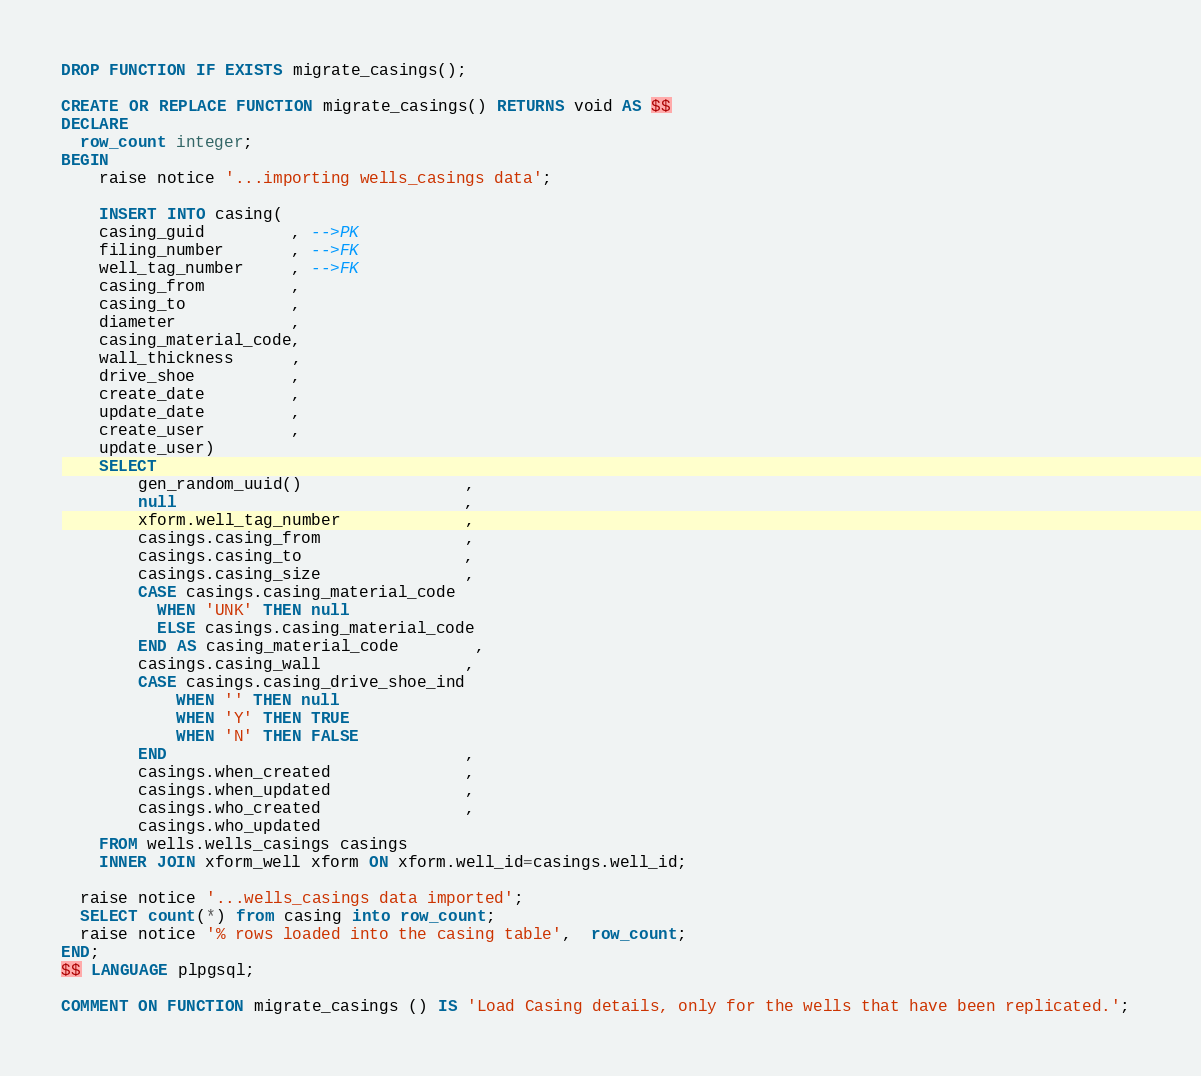Convert code to text. <code><loc_0><loc_0><loc_500><loc_500><_SQL_>DROP FUNCTION IF EXISTS migrate_casings();

CREATE OR REPLACE FUNCTION migrate_casings() RETURNS void AS $$
DECLARE
  row_count integer;
BEGIN
    raise notice '...importing wells_casings data';

    INSERT INTO casing(
    casing_guid         , -->PK
    filing_number       , -->FK
    well_tag_number     , -->FK
    casing_from         ,
    casing_to           ,
    diameter            ,
    casing_material_code,   
    wall_thickness      ,
    drive_shoe          ,
    create_date         ,
    update_date         ,
    create_user         ,
    update_user)
    SELECT
        gen_random_uuid()                 ,
        null                              ,
        xform.well_tag_number             ,
        casings.casing_from               ,
        casings.casing_to                 ,
        casings.casing_size               ,
        CASE casings.casing_material_code
          WHEN 'UNK' THEN null
          ELSE casings.casing_material_code
        END AS casing_material_code        ,
        casings.casing_wall               ,
        CASE casings.casing_drive_shoe_ind
            WHEN '' THEN null
            WHEN 'Y' THEN TRUE
            WHEN 'N' THEN FALSE
        END                               ,
        casings.when_created              ,
        casings.when_updated              ,
        casings.who_created               ,
        casings.who_updated
    FROM wells.wells_casings casings 
    INNER JOIN xform_well xform ON xform.well_id=casings.well_id;

  raise notice '...wells_casings data imported';
  SELECT count(*) from casing into row_count;
  raise notice '% rows loaded into the casing table',  row_count;
END;
$$ LANGUAGE plpgsql;

COMMENT ON FUNCTION migrate_casings () IS 'Load Casing details, only for the wells that have been replicated.'; </code> 